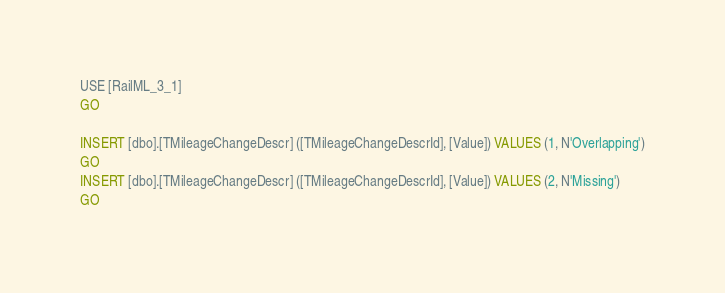Convert code to text. <code><loc_0><loc_0><loc_500><loc_500><_SQL_>USE [RailML_3_1]
GO

INSERT [dbo].[TMileageChangeDescr] ([TMileageChangeDescrId], [Value]) VALUES (1, N'Overlapping')
GO
INSERT [dbo].[TMileageChangeDescr] ([TMileageChangeDescrId], [Value]) VALUES (2, N'Missing')
GO
</code> 